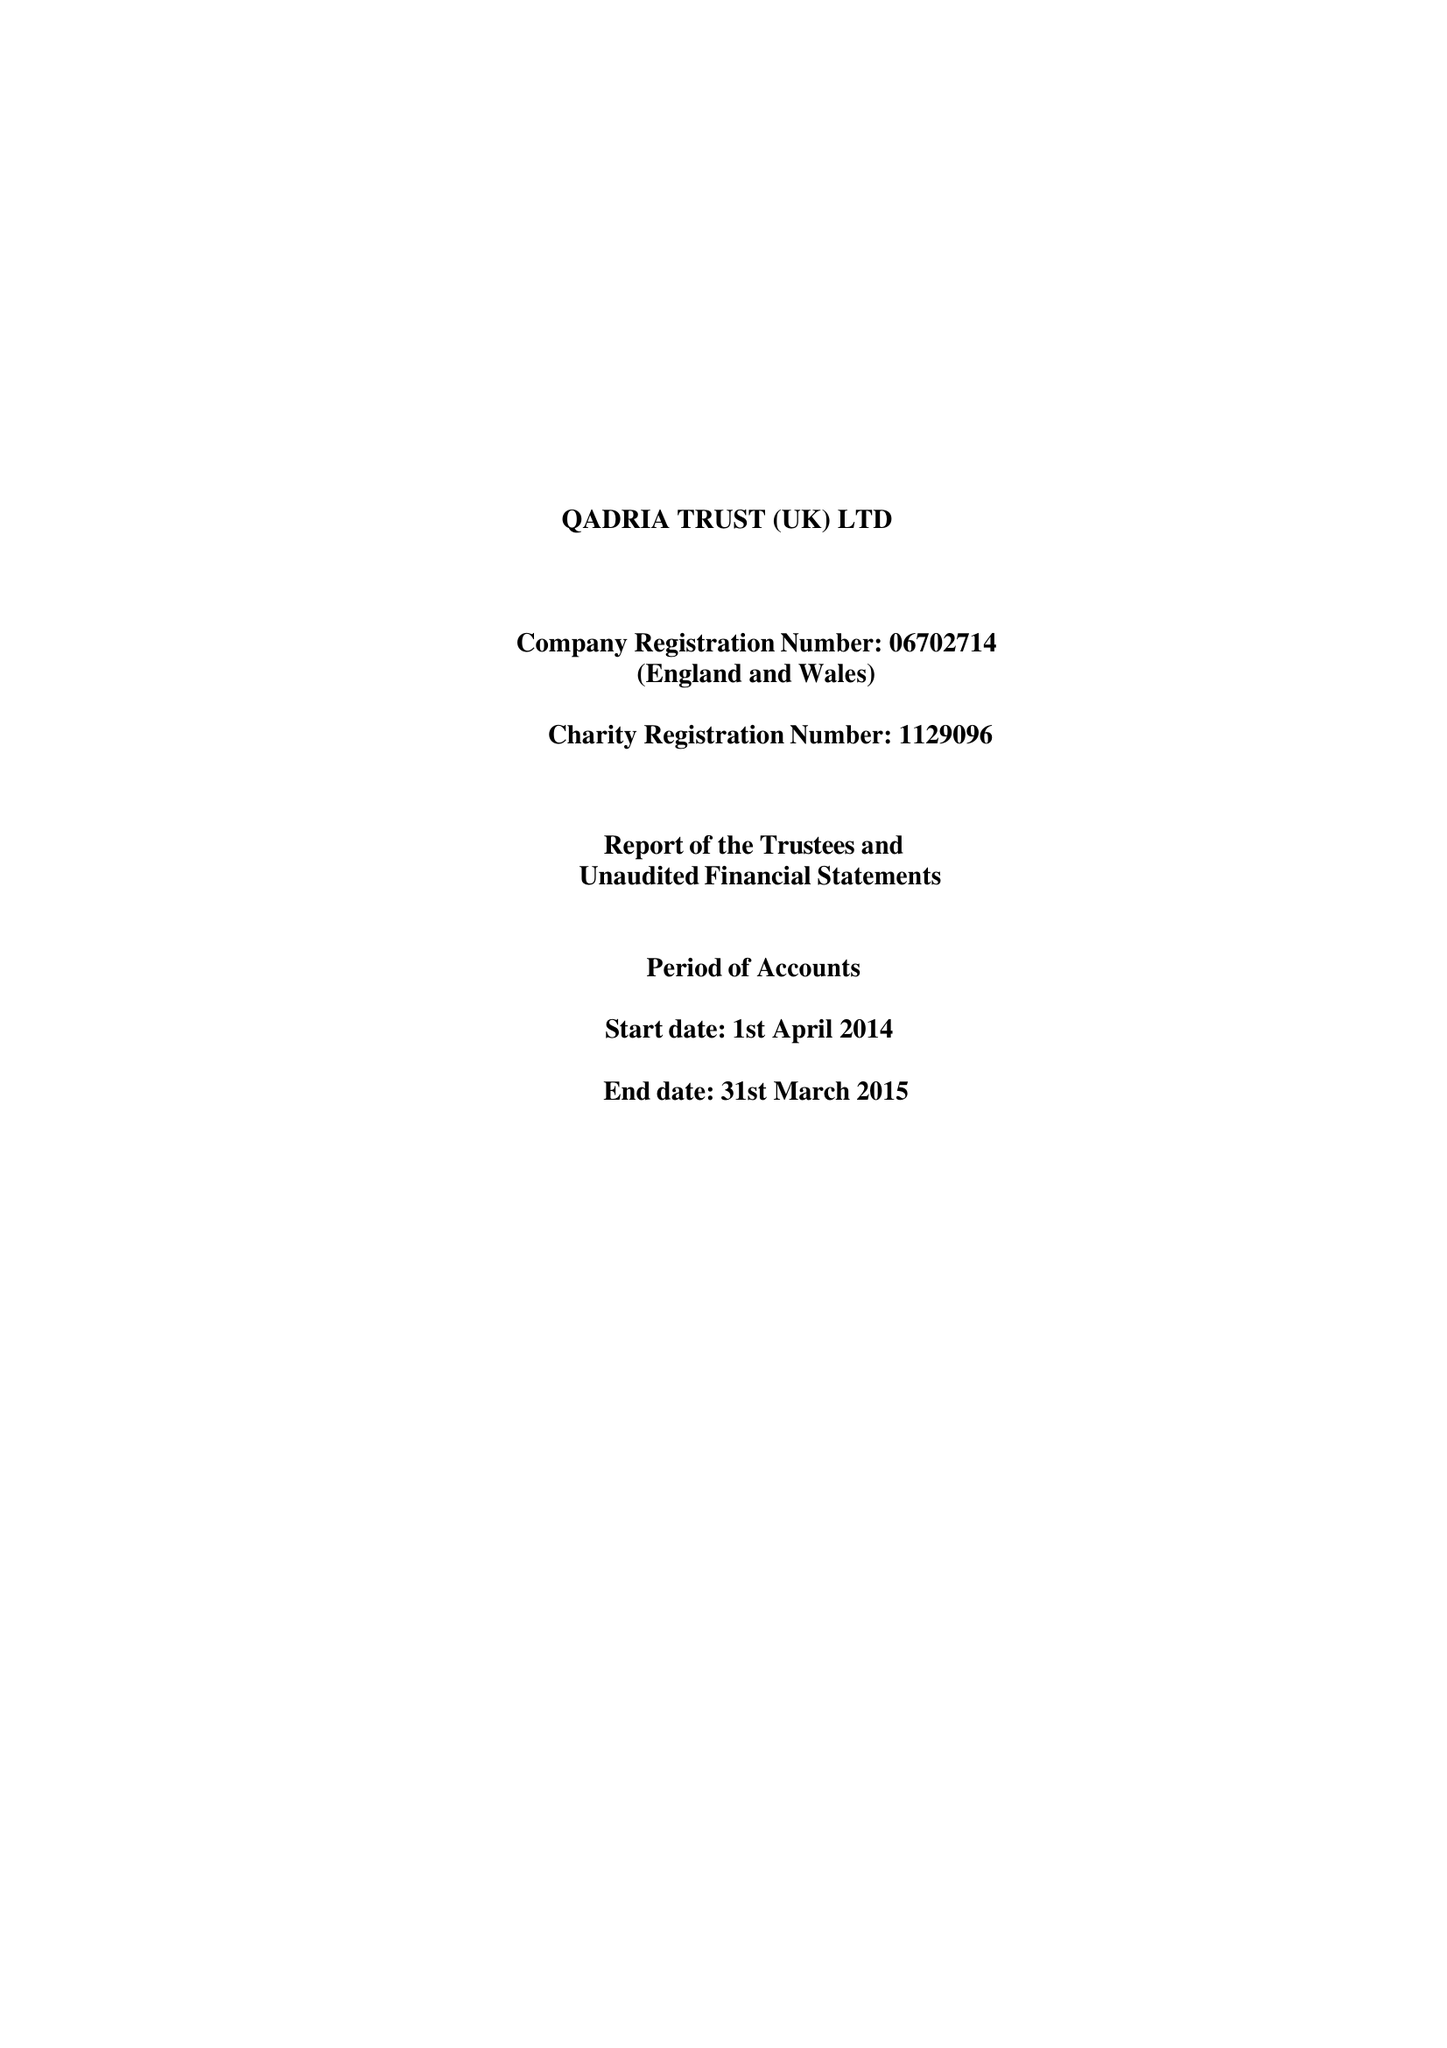What is the value for the charity_number?
Answer the question using a single word or phrase. 1129096 